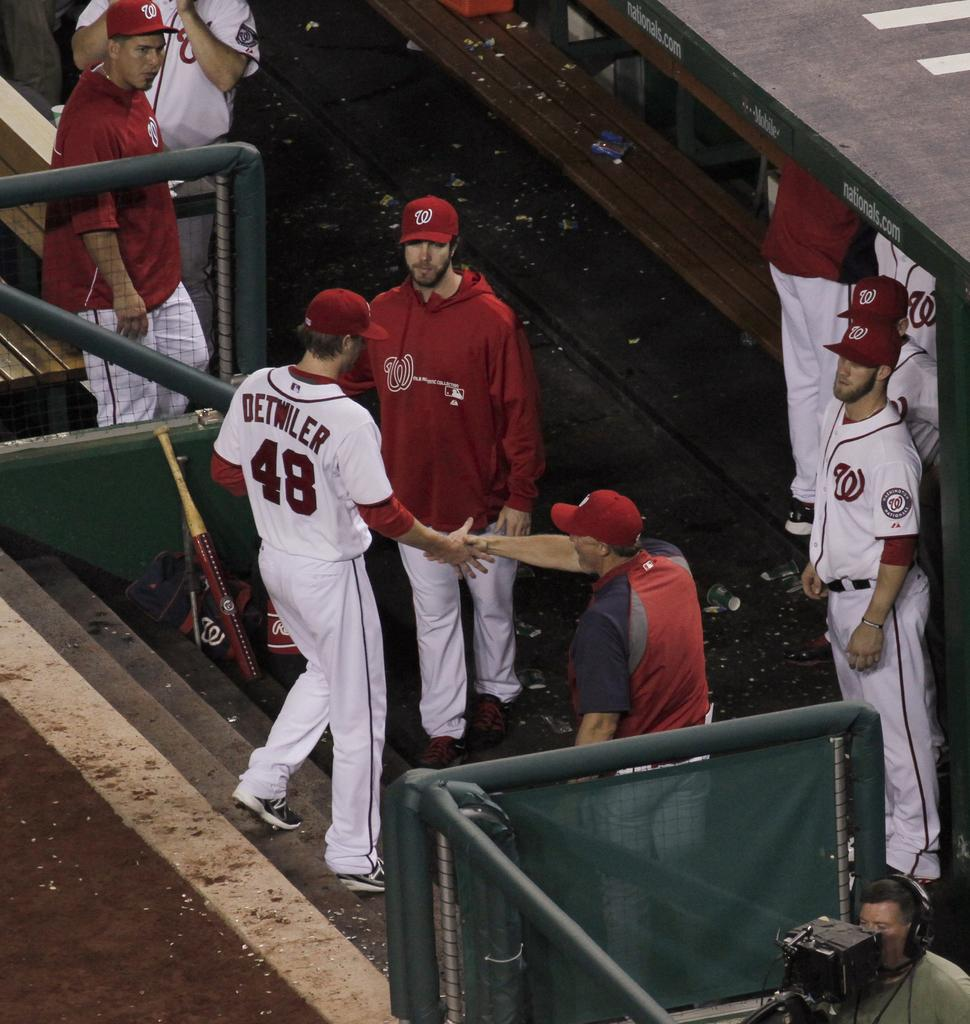<image>
Create a compact narrative representing the image presented. A group of baseball players are in the dug out including number 48. 